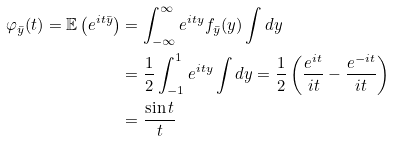Convert formula to latex. <formula><loc_0><loc_0><loc_500><loc_500>\varphi _ { \bar { y } } ( t ) = \mathbb { E } \left ( e ^ { i t \bar { y } } \right ) & = \int _ { - \infty } ^ { \infty } e ^ { i t y } f _ { \bar { y } } ( y ) \int d { y } \\ & = \frac { 1 } { 2 } \int _ { - 1 } ^ { 1 } e ^ { i t y } \int d { y } = \frac { 1 } { 2 } \left ( \frac { e ^ { i t } } { i t } - \frac { e ^ { - i t } } { i t } \right ) \\ & = \frac { \sin t } { t }</formula> 